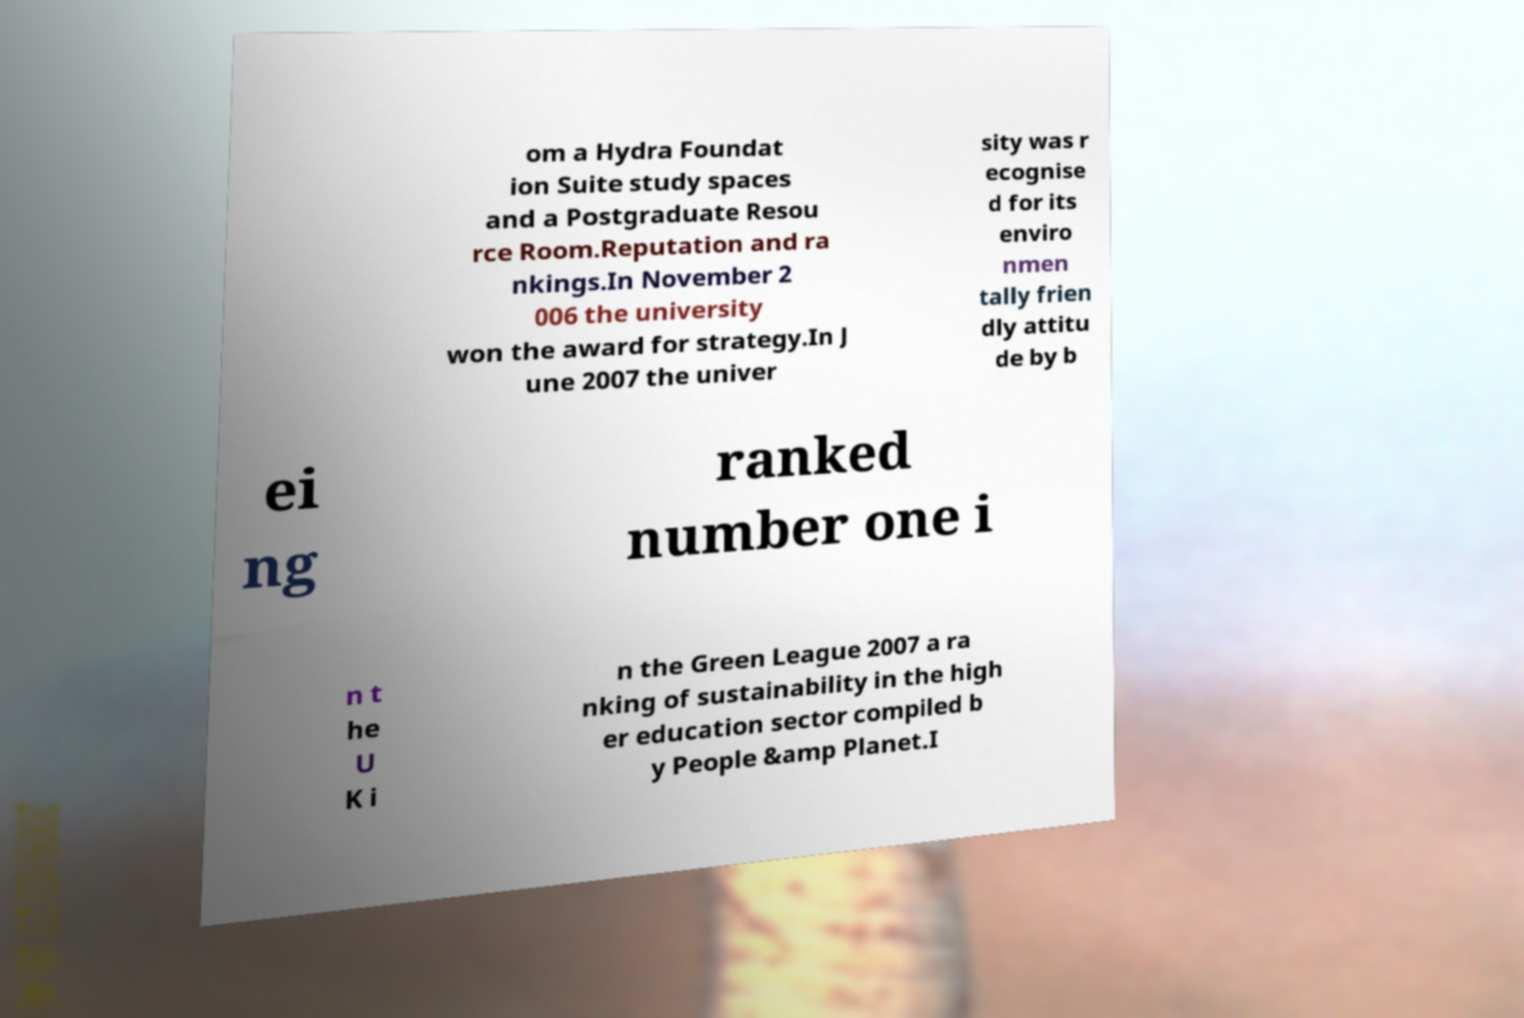Could you assist in decoding the text presented in this image and type it out clearly? om a Hydra Foundat ion Suite study spaces and a Postgraduate Resou rce Room.Reputation and ra nkings.In November 2 006 the university won the award for strategy.In J une 2007 the univer sity was r ecognise d for its enviro nmen tally frien dly attitu de by b ei ng ranked number one i n t he U K i n the Green League 2007 a ra nking of sustainability in the high er education sector compiled b y People &amp Planet.I 